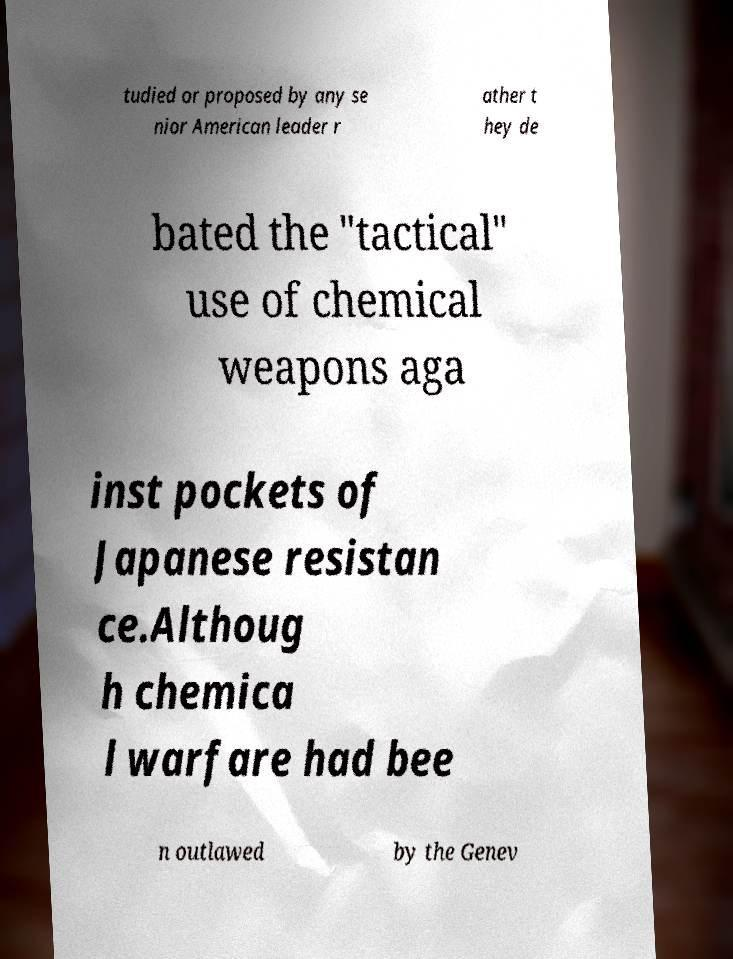What messages or text are displayed in this image? I need them in a readable, typed format. tudied or proposed by any se nior American leader r ather t hey de bated the "tactical" use of chemical weapons aga inst pockets of Japanese resistan ce.Althoug h chemica l warfare had bee n outlawed by the Genev 